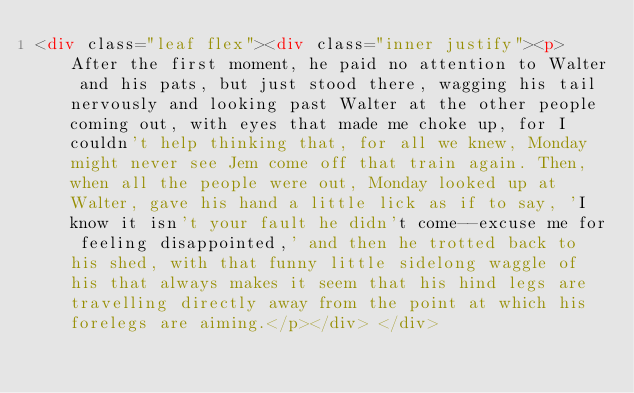Convert code to text. <code><loc_0><loc_0><loc_500><loc_500><_HTML_><div class="leaf flex"><div class="inner justify"><p> After the first moment, he paid no attention to Walter and his pats, but just stood there, wagging his tail nervously and looking past Walter at the other people coming out, with eyes that made me choke up, for I couldn't help thinking that, for all we knew, Monday might never see Jem come off that train again. Then, when all the people were out, Monday looked up at Walter, gave his hand a little lick as if to say, 'I know it isn't your fault he didn't come--excuse me for feeling disappointed,' and then he trotted back to his shed, with that funny little sidelong waggle of his that always makes it seem that his hind legs are travelling directly away from the point at which his forelegs are aiming.</p></div> </div></code> 